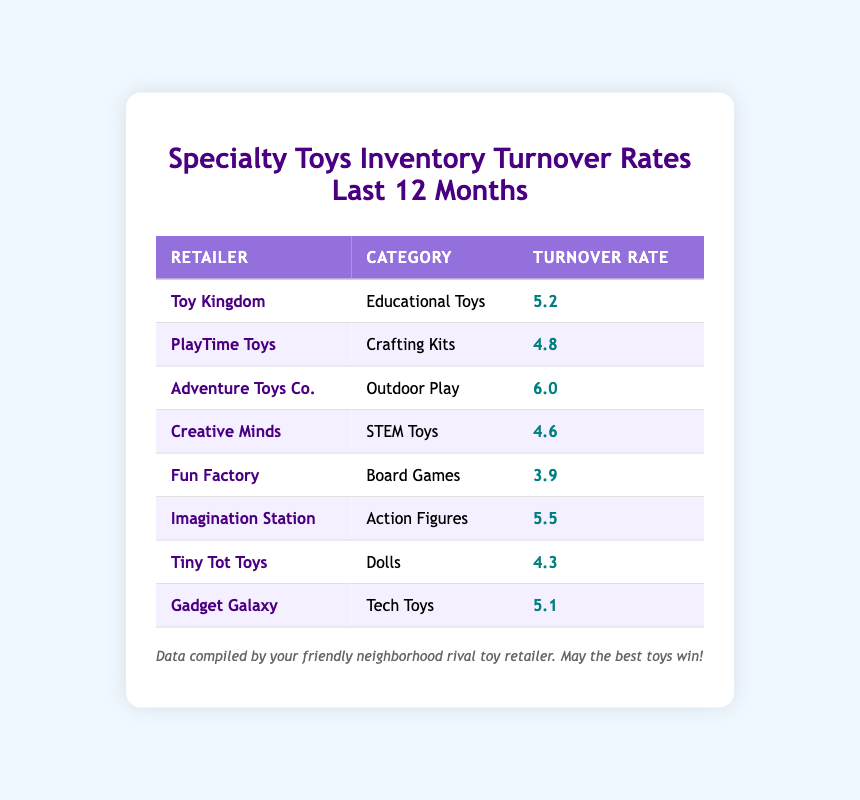What is the highest inventory turnover rate listed in the table? By analyzing the "Turnover Rate" column, the highest value is identified, which is 6.0 belonging to "Adventure Toys Co."
Answer: 6.0 Which retailer has the lowest inventory turnover rate? Scanning through the "Turnover Rate" column, the lowest value of 3.9 corresponds to "Fun Factory."
Answer: Fun Factory What is the average inventory turnover rate for all retailers in the table? Adding all the turnover rates (5.2 + 4.8 + 6.0 + 4.6 + 3.9 + 5.5 + 4.3 + 5.1) results in a total of 35.4, and dividing this by the number of retailers (8) gives an average of 4.425.
Answer: 4.425 Is there any retailer in the table that has a turnover rate of 5.0 or higher? Looking at the turnover rates, both "Adventure Toys Co." (6.0) and "Imagination Station" (5.5) exceed 5.0, so the statement is true.
Answer: Yes How many retailers have a turnover rate below 5.0? Counting the turnover rates less than 5.0, we find "PlayTime Toys" (4.8), "Creative Minds" (4.6), "Tiny Tot Toys" (4.3), and "Fun Factory" (3.9), summing to 4 retailers.
Answer: 4 Which category of toys has the highest turnover among the listed retailers? Checking the categories and their corresponding turnover rates, "Adventure Toys Co." (Outdoor Play) has the highest rate at 6.0, indicating that this is the category with the highest inventory turnover.
Answer: Outdoor Play What is the difference in turnover rate between "Imagination Station" and "Tiny Tot Toys"? "Imagination Station" shows a turnover rate of 5.5 while "Tiny Tot Toys" has 4.3. The difference is calculated as 5.5 - 4.3 = 1.2.
Answer: 1.2 Are there more retailers with turnover rates greater than 4.5 than those with rates below 4.5? The rates greater than 4.5 include: "Toy Kingdom" (5.2), "Adventure Toys Co." (6.0), "Imagination Station" (5.5), "Gadget Galaxy" (5.1) totaling 4 retailers, while those below (4.8, 4.6, 4.3, and 3.9) total 4 as well. Thus, they are equal.
Answer: No 